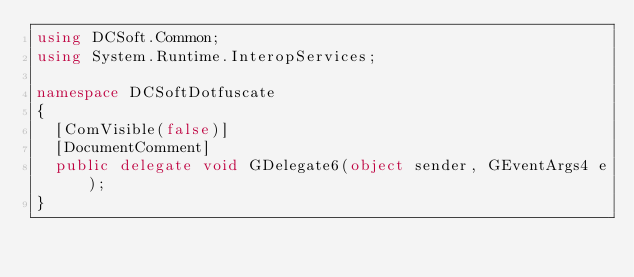Convert code to text. <code><loc_0><loc_0><loc_500><loc_500><_C#_>using DCSoft.Common;
using System.Runtime.InteropServices;

namespace DCSoftDotfuscate
{
	[ComVisible(false)]
	[DocumentComment]
	public delegate void GDelegate6(object sender, GEventArgs4 e);
}
</code> 